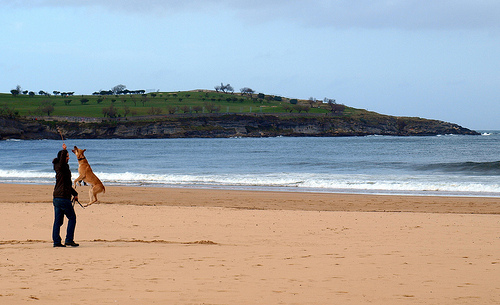Can you tell me more about what the person is doing? Certainly! The person in the image appears to be preparing to fly a kite on the beach. They are standing on the sand with the kite unfurled, likely waiting for a gust of wind to lift it into the sky. 